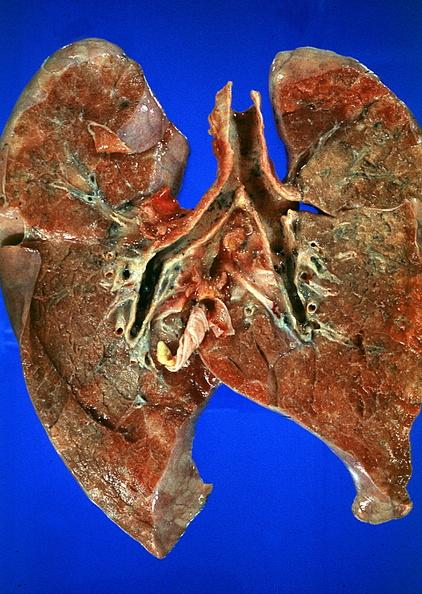s clostridial postmortem growth present?
Answer the question using a single word or phrase. No 